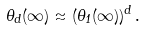<formula> <loc_0><loc_0><loc_500><loc_500>\theta _ { d } ( \infty ) \approx ( \theta _ { 1 } ( \infty ) ) ^ { d } \, .</formula> 